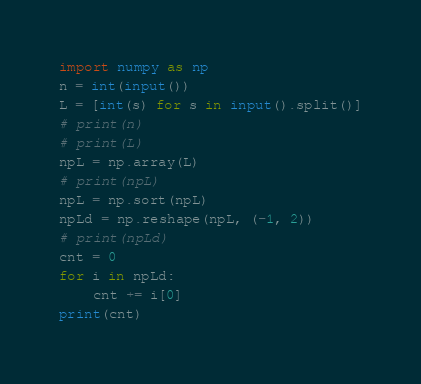Convert code to text. <code><loc_0><loc_0><loc_500><loc_500><_Python_>import numpy as np
n = int(input())
L = [int(s) for s in input().split()]
# print(n)
# print(L)
npL = np.array(L)
# print(npL)
npL = np.sort(npL)
npLd = np.reshape(npL, (-1, 2))
# print(npLd)
cnt = 0
for i in npLd:
    cnt += i[0]
print(cnt)</code> 